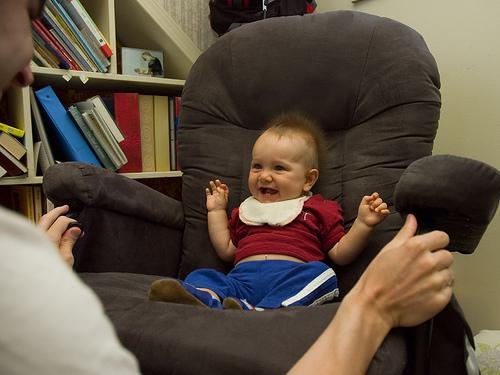Can you describe the clothing the baby is wearing? The baby is dressed in a comfy-looking outfit, with a white bib around his neck, a red top, and dark blue pants. These clothes seem soft and appropriate for a child of his age, emphasizing comfort and mobility. 